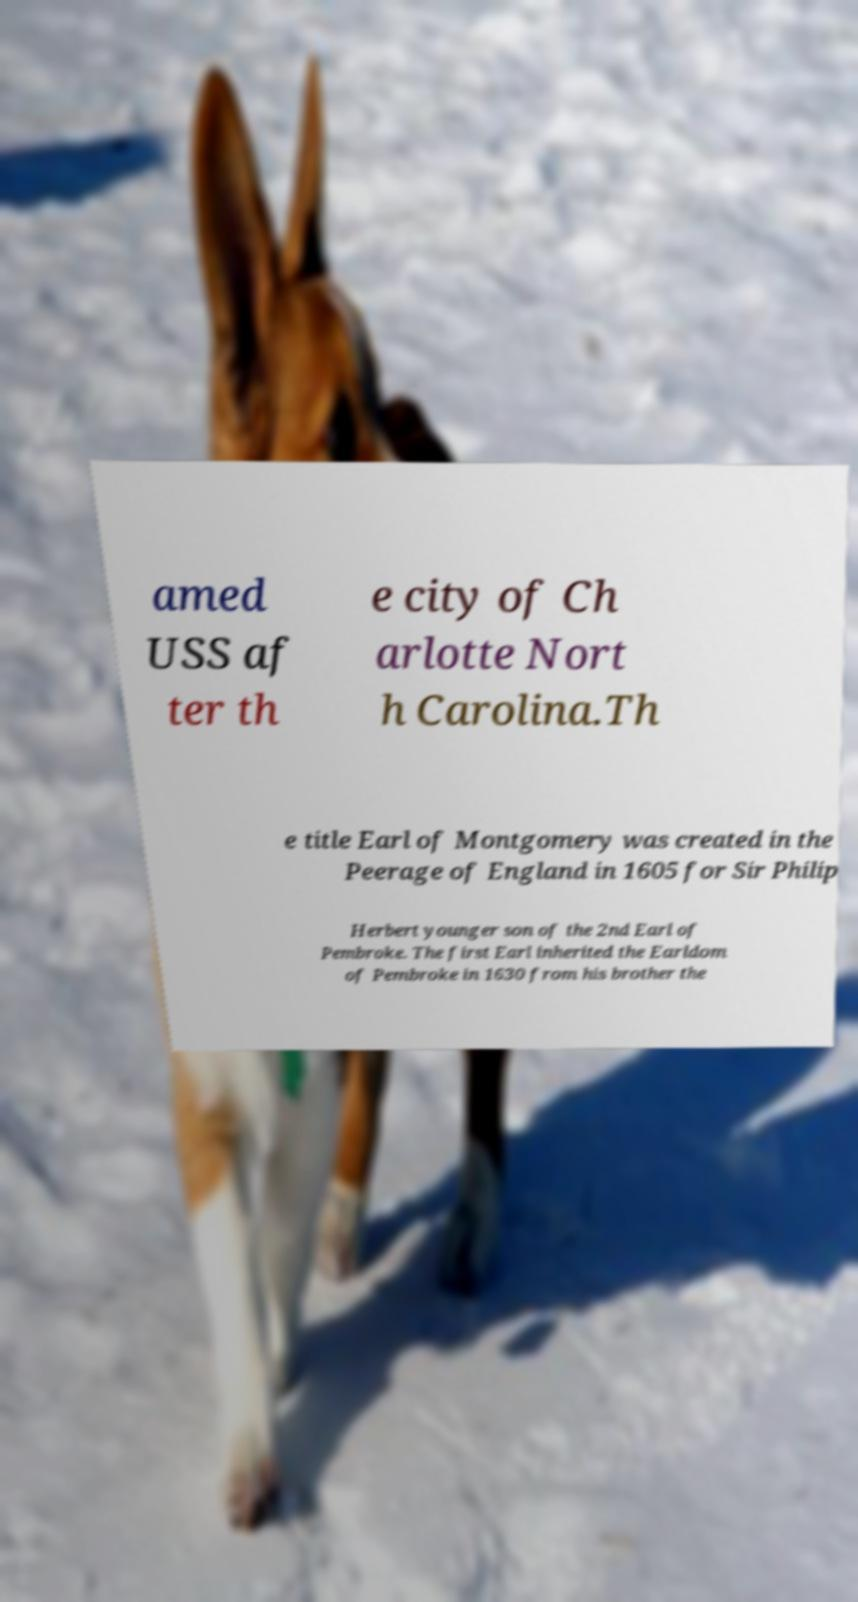Can you accurately transcribe the text from the provided image for me? amed USS af ter th e city of Ch arlotte Nort h Carolina.Th e title Earl of Montgomery was created in the Peerage of England in 1605 for Sir Philip Herbert younger son of the 2nd Earl of Pembroke. The first Earl inherited the Earldom of Pembroke in 1630 from his brother the 